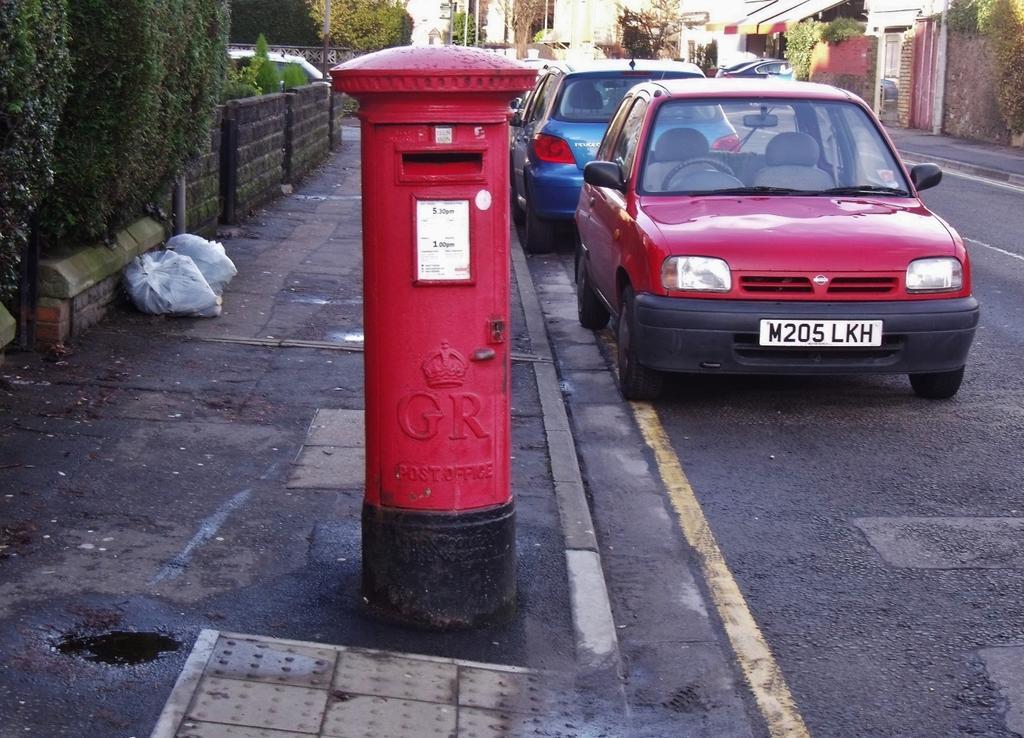Describe this image in one or two sentences. At the bottom of the image on the left side there is a footpath. On the footpath there is a post box and also there are covers. There is a fencing wall. Behind the fencing wall there are trees. And on the right side of the image on the road there are vehicles. And in the background there are trees and walls. 